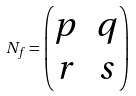Convert formula to latex. <formula><loc_0><loc_0><loc_500><loc_500>N _ { f } = \begin{pmatrix} p & q \\ r & s \end{pmatrix}</formula> 